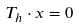Convert formula to latex. <formula><loc_0><loc_0><loc_500><loc_500>T _ { h } \cdot x = 0</formula> 